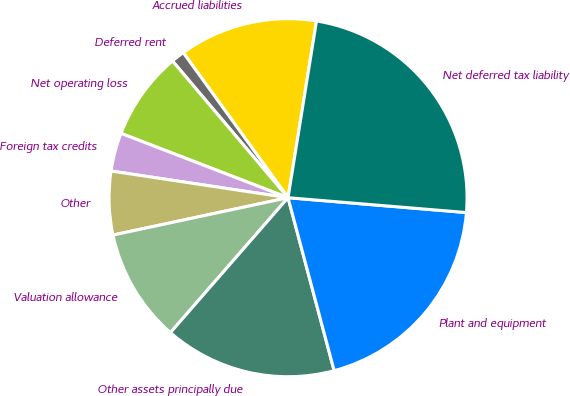Convert chart to OTSL. <chart><loc_0><loc_0><loc_500><loc_500><pie_chart><fcel>Accrued liabilities<fcel>Deferred rent<fcel>Net operating loss<fcel>Foreign tax credits<fcel>Other<fcel>Valuation allowance<fcel>Other assets principally due<fcel>Plant and equipment<fcel>Net deferred tax liability<nl><fcel>12.5%<fcel>1.21%<fcel>7.98%<fcel>3.47%<fcel>5.73%<fcel>10.24%<fcel>15.56%<fcel>19.53%<fcel>23.78%<nl></chart> 